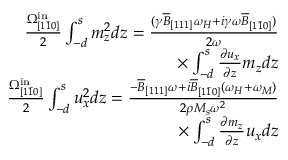<formula> <loc_0><loc_0><loc_500><loc_500>\begin{array} { r } { \frac { \Omega _ { [ 1 \bar { 1 } 0 ] } ^ { i n } } { 2 } \int _ { - d } ^ { s } m _ { z } ^ { 2 } d z = \frac { ( \gamma \overline { B } _ { [ 1 1 1 ] } \omega _ { H } + i \gamma \omega \overline { B } _ { [ 1 \bar { 1 } 0 ] } ) } { 2 \omega } } \\ { \times \int _ { - d } ^ { s } \frac { \partial u _ { x } } { \partial z } m _ { z } d z } \\ { \frac { \Omega _ { [ 1 \bar { 1 } 0 ] } ^ { i n } } { 2 } \int _ { - d } ^ { s } u _ { x } ^ { 2 } d z = \frac { - \overline { B } _ { [ 1 1 1 ] } \omega + i \overline { B } _ { [ 1 \bar { 1 } 0 ] } ( \omega _ { H } + \omega _ { M } ) } { 2 \rho M _ { s } \omega ^ { 2 } } } \\ { \times \int _ { - d } ^ { s } \frac { \partial m _ { z } } { \partial z } u _ { x } d z } \end{array}</formula> 